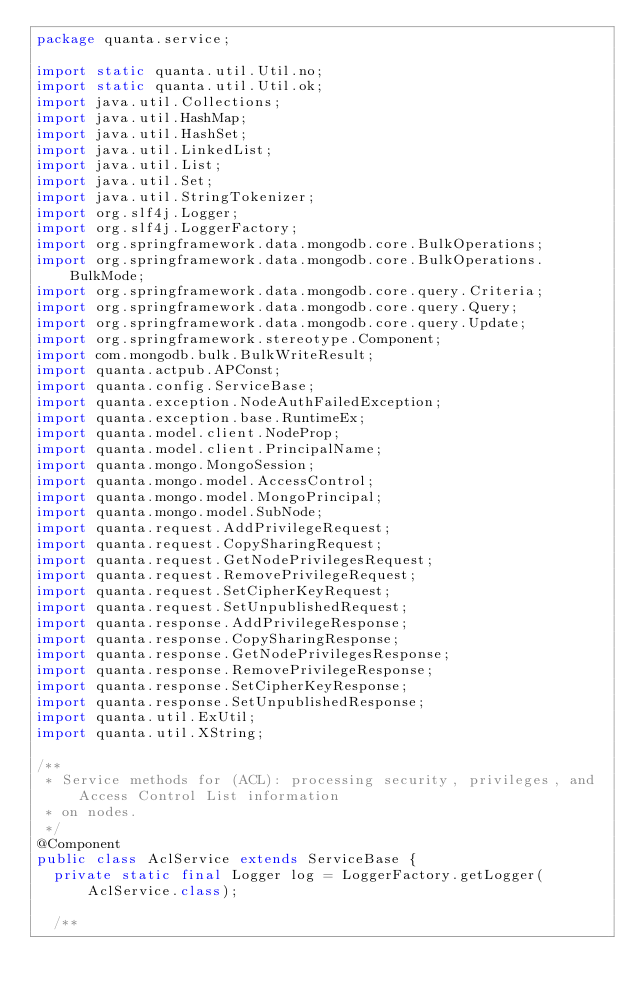<code> <loc_0><loc_0><loc_500><loc_500><_Java_>package quanta.service;

import static quanta.util.Util.no;
import static quanta.util.Util.ok;
import java.util.Collections;
import java.util.HashMap;
import java.util.HashSet;
import java.util.LinkedList;
import java.util.List;
import java.util.Set;
import java.util.StringTokenizer;
import org.slf4j.Logger;
import org.slf4j.LoggerFactory;
import org.springframework.data.mongodb.core.BulkOperations;
import org.springframework.data.mongodb.core.BulkOperations.BulkMode;
import org.springframework.data.mongodb.core.query.Criteria;
import org.springframework.data.mongodb.core.query.Query;
import org.springframework.data.mongodb.core.query.Update;
import org.springframework.stereotype.Component;
import com.mongodb.bulk.BulkWriteResult;
import quanta.actpub.APConst;
import quanta.config.ServiceBase;
import quanta.exception.NodeAuthFailedException;
import quanta.exception.base.RuntimeEx;
import quanta.model.client.NodeProp;
import quanta.model.client.PrincipalName;
import quanta.mongo.MongoSession;
import quanta.mongo.model.AccessControl;
import quanta.mongo.model.MongoPrincipal;
import quanta.mongo.model.SubNode;
import quanta.request.AddPrivilegeRequest;
import quanta.request.CopySharingRequest;
import quanta.request.GetNodePrivilegesRequest;
import quanta.request.RemovePrivilegeRequest;
import quanta.request.SetCipherKeyRequest;
import quanta.request.SetUnpublishedRequest;
import quanta.response.AddPrivilegeResponse;
import quanta.response.CopySharingResponse;
import quanta.response.GetNodePrivilegesResponse;
import quanta.response.RemovePrivilegeResponse;
import quanta.response.SetCipherKeyResponse;
import quanta.response.SetUnpublishedResponse;
import quanta.util.ExUtil;
import quanta.util.XString;

/**
 * Service methods for (ACL): processing security, privileges, and Access Control List information
 * on nodes.
 */
@Component
public class AclService extends ServiceBase {
	private static final Logger log = LoggerFactory.getLogger(AclService.class);

	/**</code> 